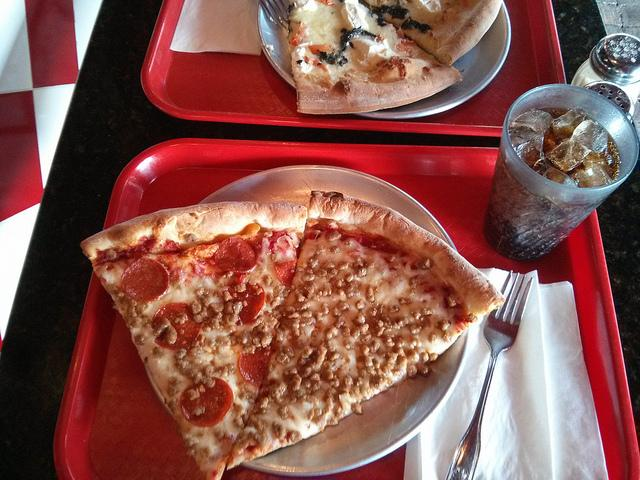Where was this pizza purchased? Please explain your reasoning. restaurant. The pizza is from a restaurant. 